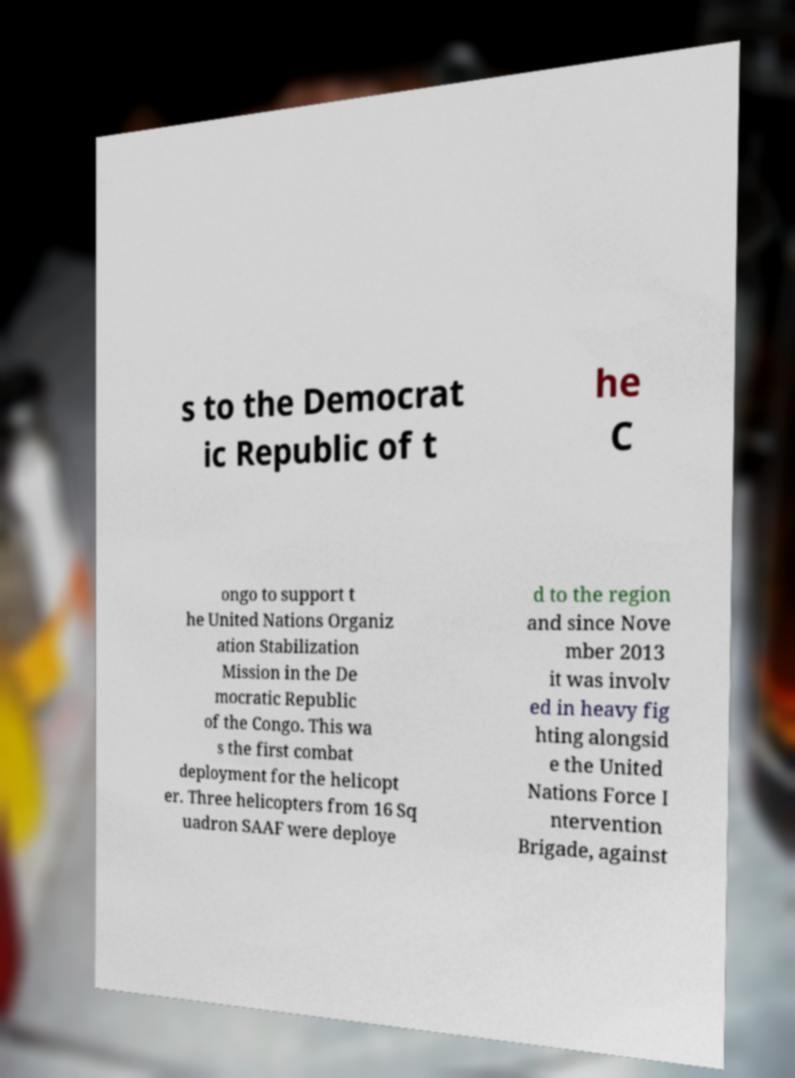Please identify and transcribe the text found in this image. s to the Democrat ic Republic of t he C ongo to support t he United Nations Organiz ation Stabilization Mission in the De mocratic Republic of the Congo. This wa s the first combat deployment for the helicopt er. Three helicopters from 16 Sq uadron SAAF were deploye d to the region and since Nove mber 2013 it was involv ed in heavy fig hting alongsid e the United Nations Force I ntervention Brigade, against 